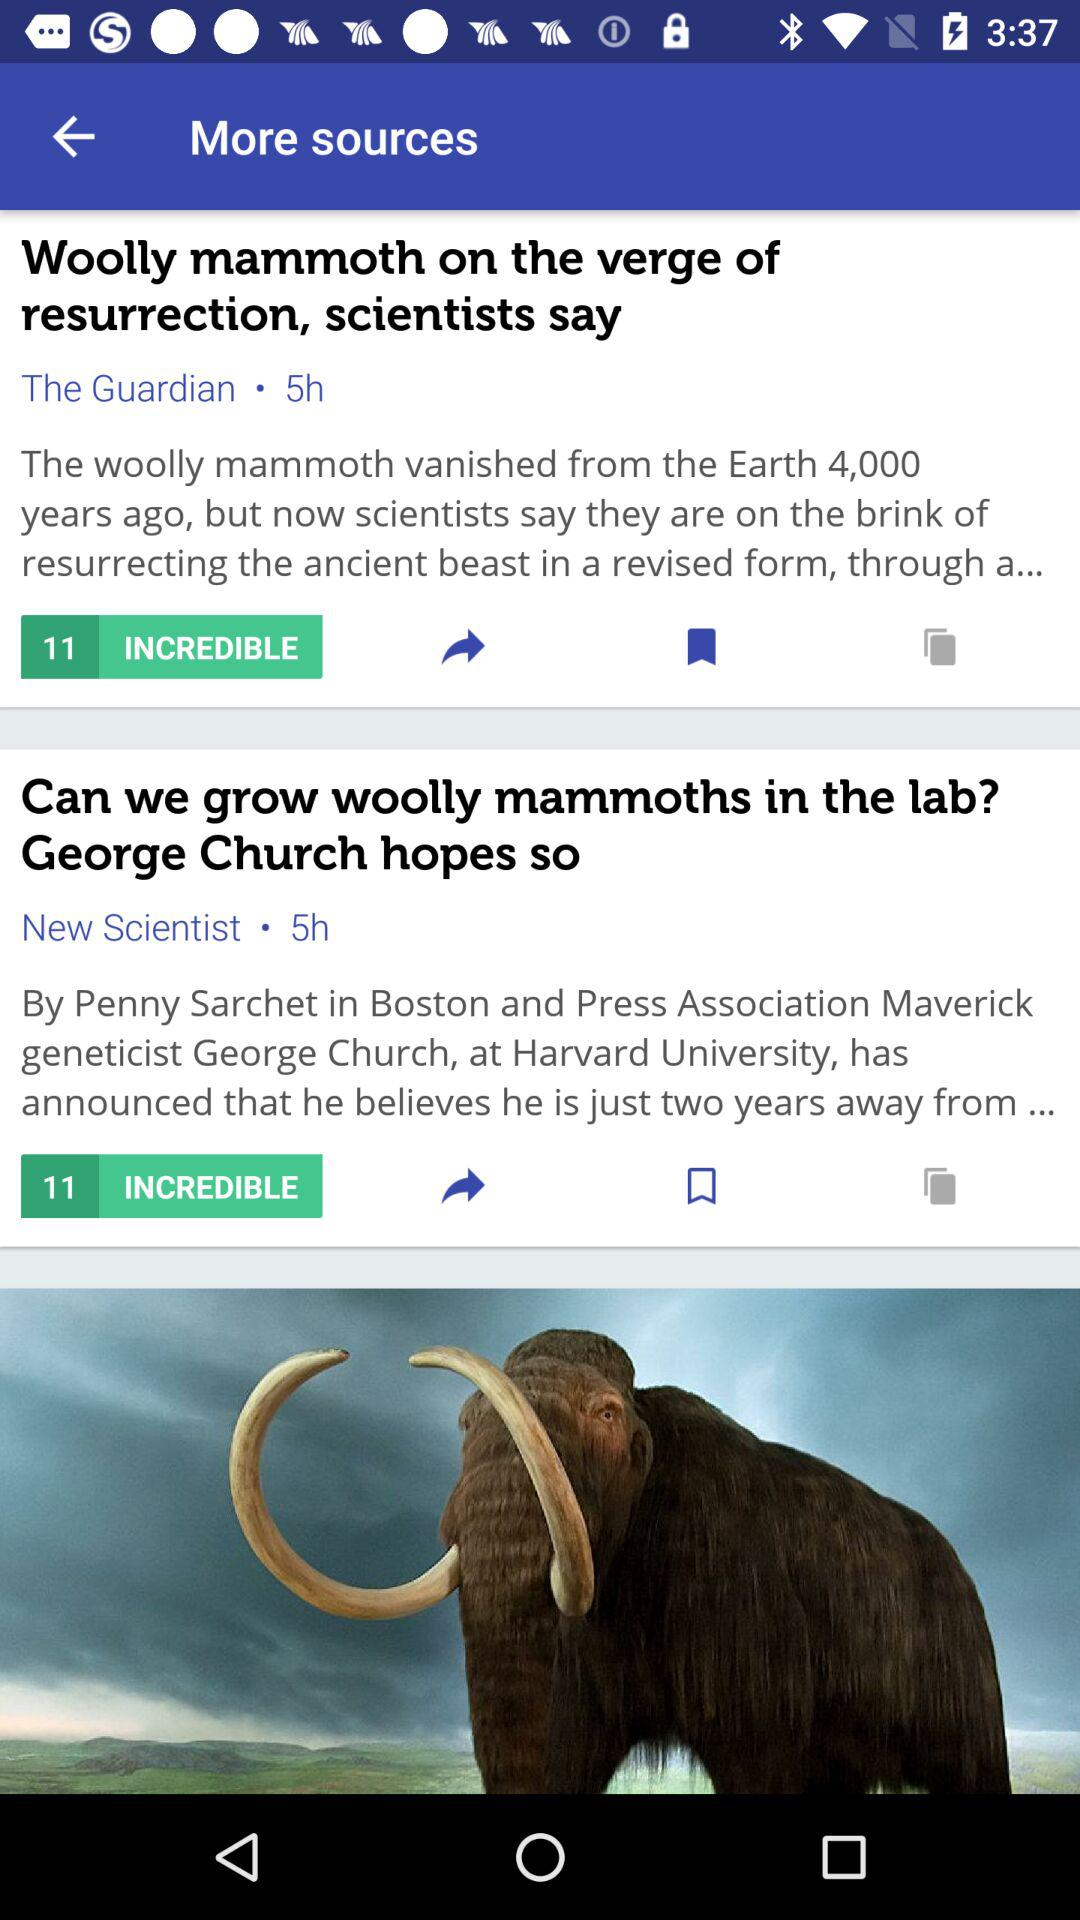Who uploaded "Can we grow woolly mammoths in the lab? George Church hopes so"? It is uploaded by "New Scientist". 